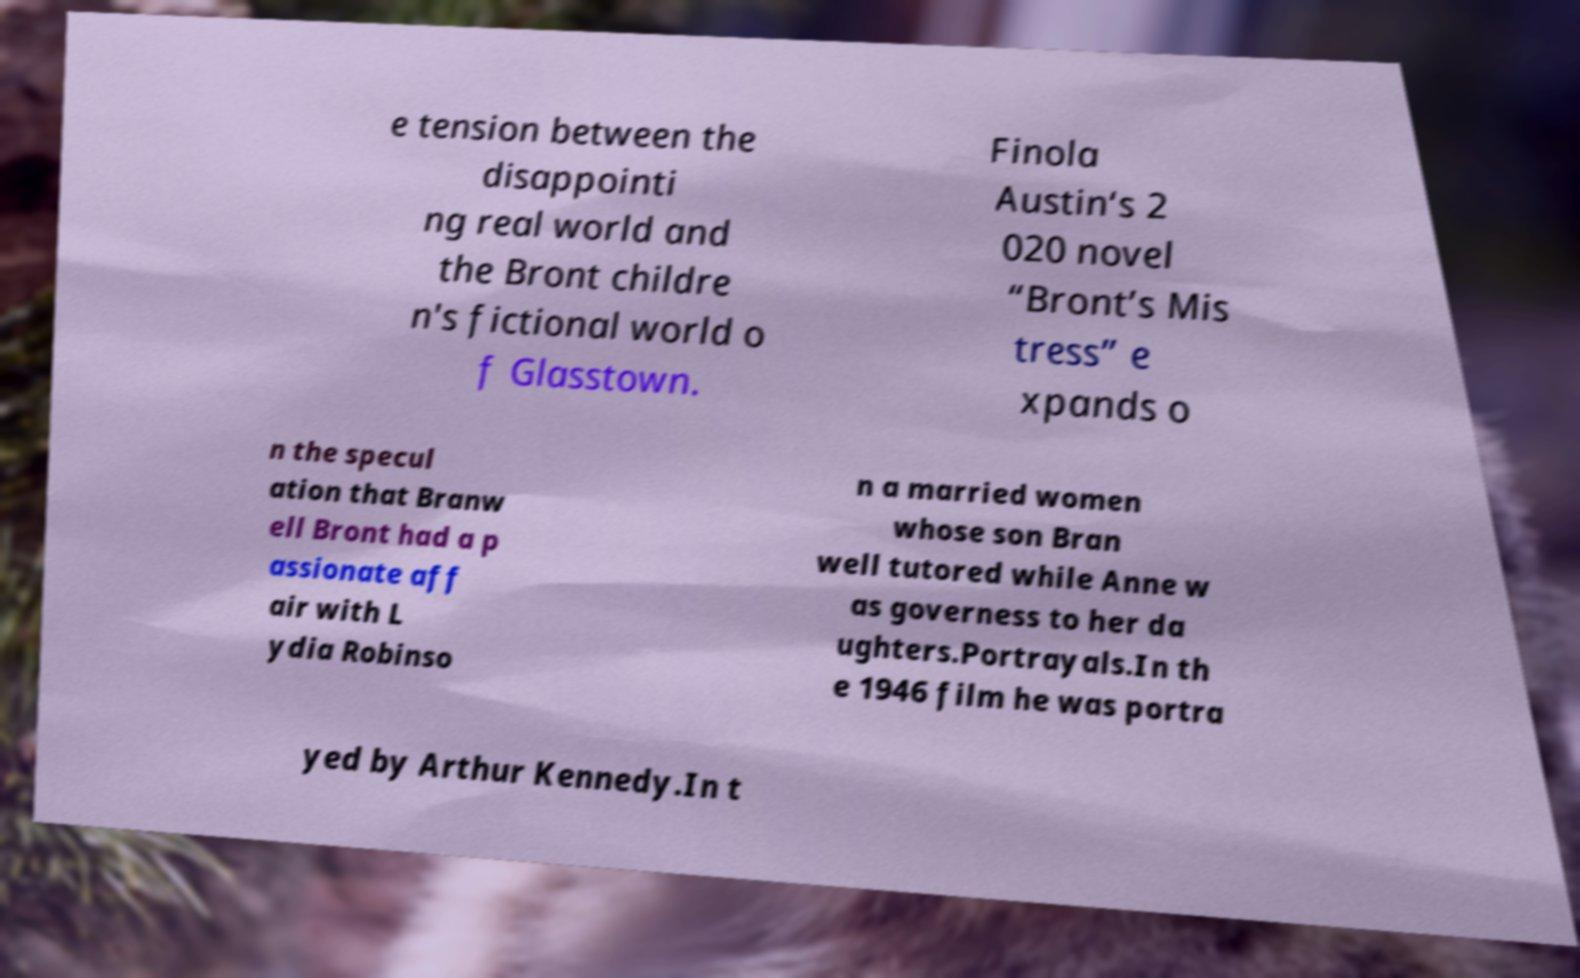Can you accurately transcribe the text from the provided image for me? e tension between the disappointi ng real world and the Bront childre n's fictional world o f Glasstown. Finola Austin‘s 2 020 novel “Bront’s Mis tress” e xpands o n the specul ation that Branw ell Bront had a p assionate aff air with L ydia Robinso n a married women whose son Bran well tutored while Anne w as governess to her da ughters.Portrayals.In th e 1946 film he was portra yed by Arthur Kennedy.In t 